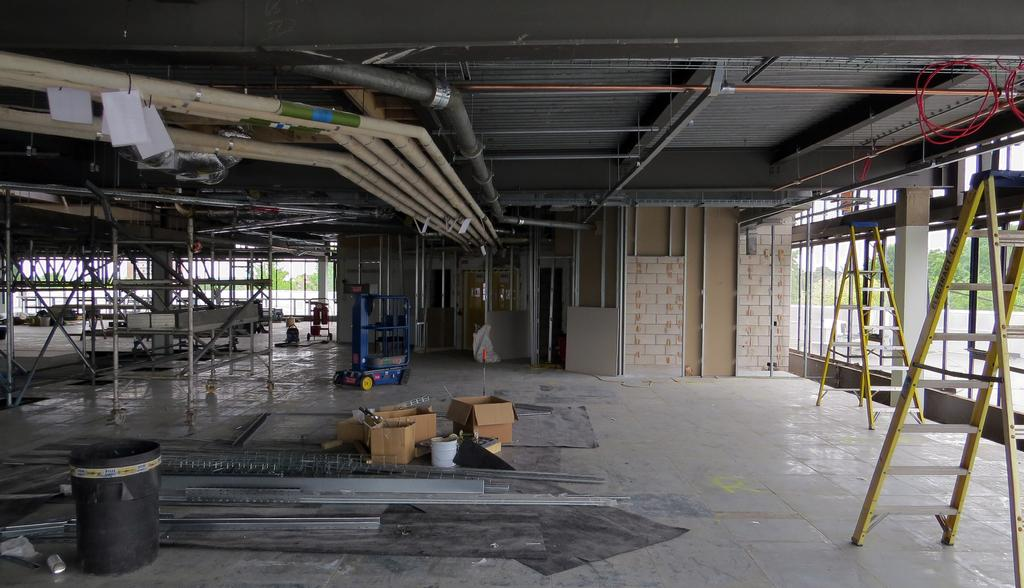What is attached to the rooftop in the image? Pipes are attached to the rooftop. What is on the floor in the image? There is a container and cardboard boxes on the floor. What equipment is visible on the floor? Ladders are visible on the floor. What type of machine is in the image? A machine is in the image. What is the rack with wheels used for? The rack with wheels is likely used for storage or transportation. What can be seen through the glasses in the image? Trees are visible through the glasses. What type of hobbies are the people in the image engaged in? There are no people visible in the image, so it is impossible to determine their hobbies. How does the jelly contribute to the functionality of the machine in the image? There is no jelly present in the image, so it cannot contribute to the functionality of the machine. 